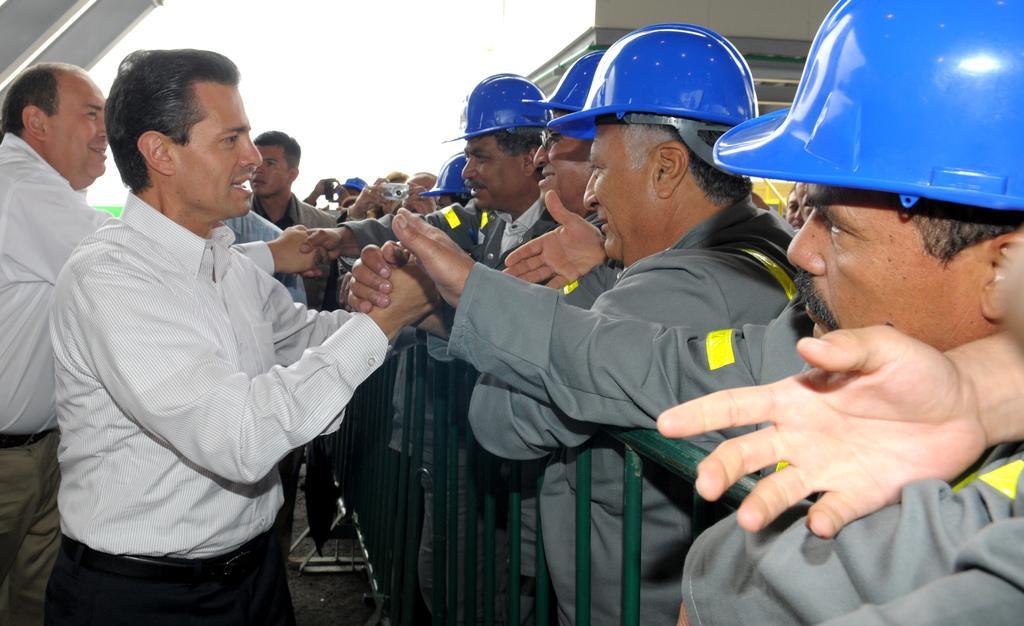Describe this image in one or two sentences. In this picture we can see some people are standing, there are barricades in the middle, the people on the right side are wearing helmets, a person in the background is holding a camera. 